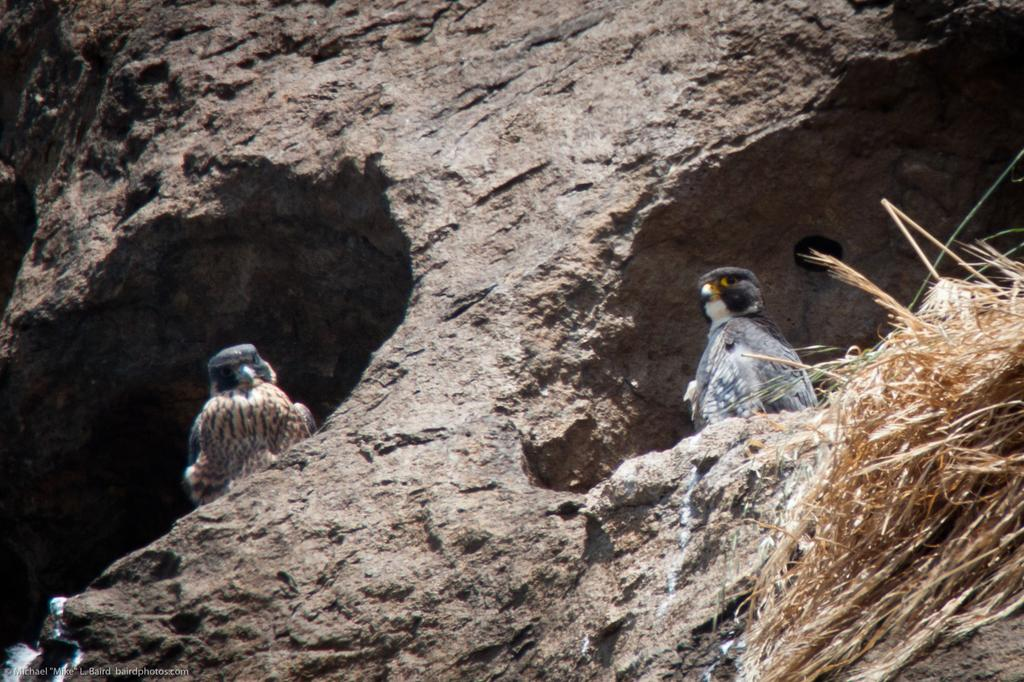How many birds are in the image? There are two birds in the image. Where are the birds located? The birds are on a rock. What type of vegetation is on the right side of the image? There is dry grass on the right side of the image. What word is being used by the birds to communicate in the image? There is no indication in the image that the birds are communicating with words. --- Facts: 1. There is a person holding a book in the image. 2. The person is sitting on a chair. 3. There is a table in front of the person. 4. The book has a blue cover. Absurd Topics: dance, ocean, bicycle Conversation: What is the person in the image holding? The person is holding a book in the image. Where is the person sitting? The person is sitting on a chair. What is in front of the person? There is a table in front of the person. What color is the book's cover? The book has a blue cover. Reasoning: Let's think step by step in order to produce the conversation. We start by identifying the main subject in the image, which is the person holding a book. Then, we describe the person's location, which is sitting on a chair. Next, we mention the presence of a table in front of the person. Finally, we describe a specific detail about the book, which is the color of its cover, which is blue. Each question is designed to elicit a specific detail about the image that is known from the provided facts. Absurd Question/Answer: What type of dance is the person performing in the image? There is no indication in the image that the person is dancing. --- Facts: 1. There is a person holding a book in the image. 2. The person is sitting on a chair. 3. There is a table in front of the person. 4. The book has a blue cover. Absurd Topics: dance ocean bicycle Conversation: What is the person in the image holding? The person is holding a book in the image. Where is the person sitting? The person is sitting on a chair. What is in front of the person? There is a table in front of the person. What is the color of the book's cover? The book has a blue cover. Reasoning: Let's think step by step in order to produce the conversation. We start by identifying the main subject in the image, which is the person holding a book. Then, we describe the person's location, which is sitting on a chair. Next, we mention the presence of a table in front of the person. Finally, we describe a specific detail about the book, which is the color of its cover, which is the blue color. Each question is designed to elicit a 